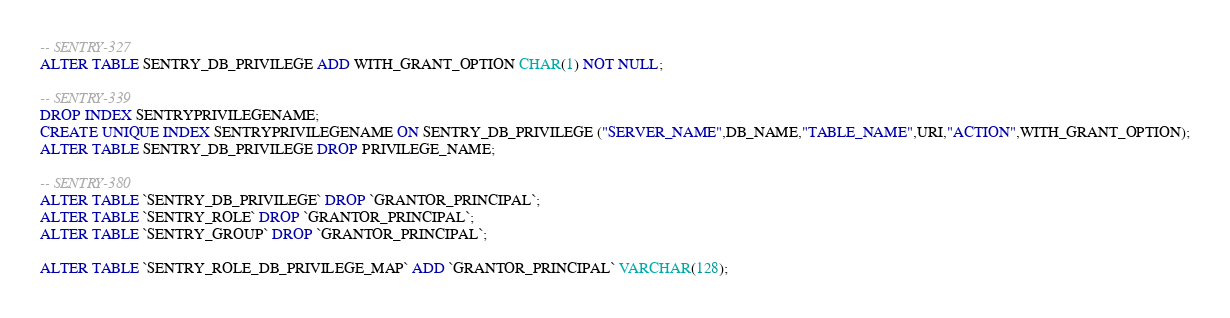<code> <loc_0><loc_0><loc_500><loc_500><_SQL_>-- SENTRY-327
ALTER TABLE SENTRY_DB_PRIVILEGE ADD WITH_GRANT_OPTION CHAR(1) NOT NULL;

-- SENTRY-339
DROP INDEX SENTRYPRIVILEGENAME;
CREATE UNIQUE INDEX SENTRYPRIVILEGENAME ON SENTRY_DB_PRIVILEGE ("SERVER_NAME",DB_NAME,"TABLE_NAME",URI,"ACTION",WITH_GRANT_OPTION);
ALTER TABLE SENTRY_DB_PRIVILEGE DROP PRIVILEGE_NAME;

-- SENTRY-380
ALTER TABLE `SENTRY_DB_PRIVILEGE` DROP `GRANTOR_PRINCIPAL`;
ALTER TABLE `SENTRY_ROLE` DROP `GRANTOR_PRINCIPAL`;
ALTER TABLE `SENTRY_GROUP` DROP `GRANTOR_PRINCIPAL`;

ALTER TABLE `SENTRY_ROLE_DB_PRIVILEGE_MAP` ADD `GRANTOR_PRINCIPAL` VARCHAR(128);</code> 